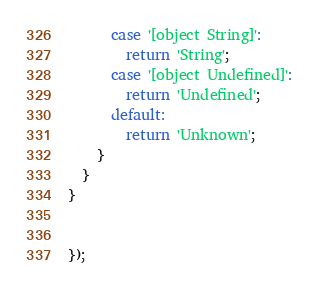<code> <loc_0><loc_0><loc_500><loc_500><_JavaScript_>      case '[object String]':
        return 'String';
      case '[object Undefined]':
        return 'Undefined';
      default:
        return 'Unknown';
    }
  }
}


});
</code> 